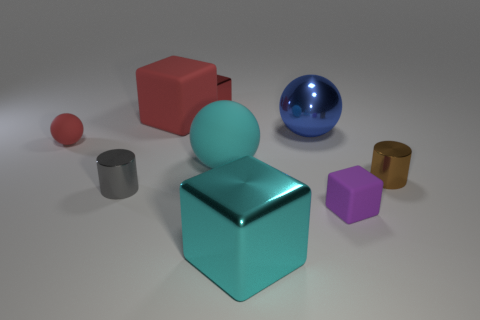What shape is the tiny red object left of the metal block that is left of the large cyan metallic thing?
Your answer should be compact. Sphere. What number of objects are purple matte balls or balls that are behind the purple block?
Provide a short and direct response. 3. What is the color of the large ball behind the big rubber object on the right side of the tiny red block behind the cyan metal object?
Give a very brief answer. Blue. What is the material of the tiny purple thing that is the same shape as the cyan metal object?
Ensure brevity in your answer.  Rubber. The large metallic block has what color?
Provide a short and direct response. Cyan. Does the large shiny cube have the same color as the tiny shiny block?
Ensure brevity in your answer.  No. How many metal objects are either gray cylinders or cyan spheres?
Provide a succinct answer. 1. There is a small metallic object on the right side of the tiny cube in front of the tiny sphere; are there any gray things to the right of it?
Make the answer very short. No. What is the size of the red cube that is the same material as the tiny purple block?
Make the answer very short. Large. There is a brown shiny cylinder; are there any small red matte objects in front of it?
Your answer should be compact. No. 